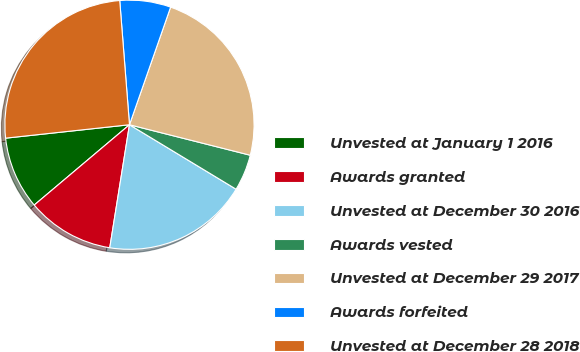<chart> <loc_0><loc_0><loc_500><loc_500><pie_chart><fcel>Unvested at January 1 2016<fcel>Awards granted<fcel>Unvested at December 30 2016<fcel>Awards vested<fcel>Unvested at December 29 2017<fcel>Awards forfeited<fcel>Unvested at December 28 2018<nl><fcel>9.43%<fcel>11.32%<fcel>18.87%<fcel>4.72%<fcel>23.58%<fcel>6.6%<fcel>25.47%<nl></chart> 